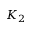<formula> <loc_0><loc_0><loc_500><loc_500>K _ { 2 }</formula> 